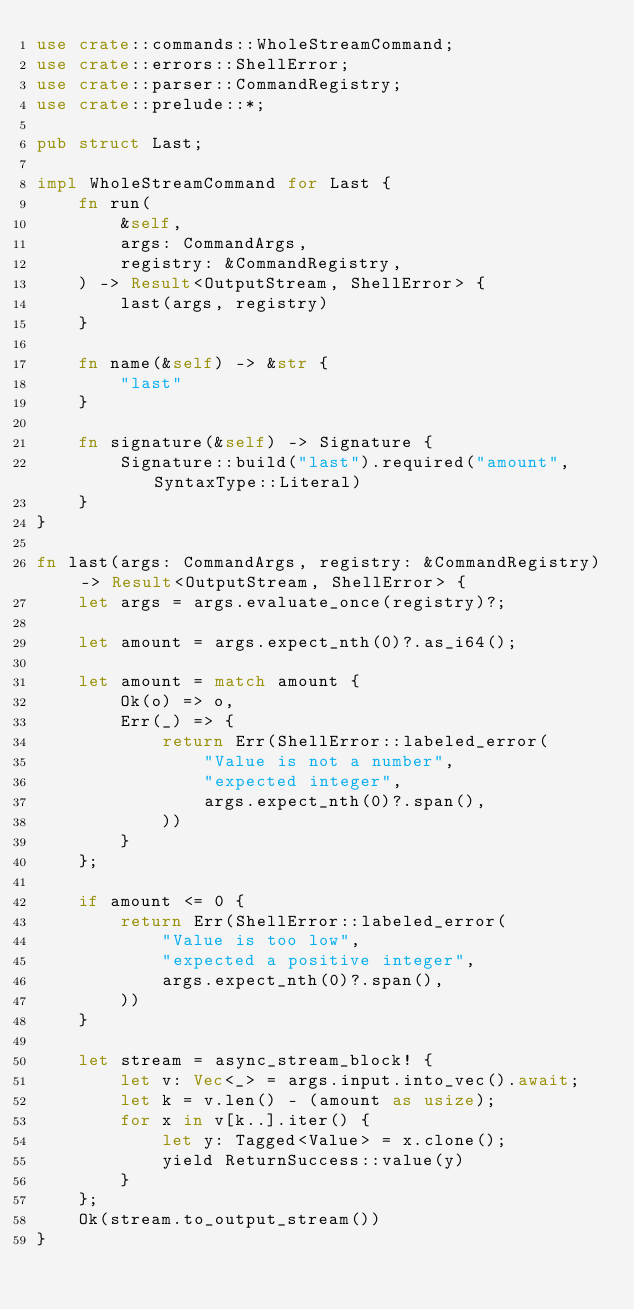<code> <loc_0><loc_0><loc_500><loc_500><_Rust_>use crate::commands::WholeStreamCommand;
use crate::errors::ShellError;
use crate::parser::CommandRegistry;
use crate::prelude::*;

pub struct Last;

impl WholeStreamCommand for Last {
    fn run(
        &self,
        args: CommandArgs,
        registry: &CommandRegistry,
    ) -> Result<OutputStream, ShellError> {
        last(args, registry)
    }

    fn name(&self) -> &str {
        "last"
    }

    fn signature(&self) -> Signature {
        Signature::build("last").required("amount", SyntaxType::Literal)
    }
}

fn last(args: CommandArgs, registry: &CommandRegistry) -> Result<OutputStream, ShellError> {
    let args = args.evaluate_once(registry)?;

    let amount = args.expect_nth(0)?.as_i64();

    let amount = match amount {
        Ok(o) => o,
        Err(_) => {
            return Err(ShellError::labeled_error(
                "Value is not a number",
                "expected integer",
                args.expect_nth(0)?.span(),
            ))
        }
    };

    if amount <= 0 {
        return Err(ShellError::labeled_error(
            "Value is too low",
            "expected a positive integer",
            args.expect_nth(0)?.span(),
        ))
    }

    let stream = async_stream_block! {
        let v: Vec<_> = args.input.into_vec().await;
        let k = v.len() - (amount as usize);
        for x in v[k..].iter() {
            let y: Tagged<Value> = x.clone();
            yield ReturnSuccess::value(y)
        }
    };
    Ok(stream.to_output_stream())
}
</code> 